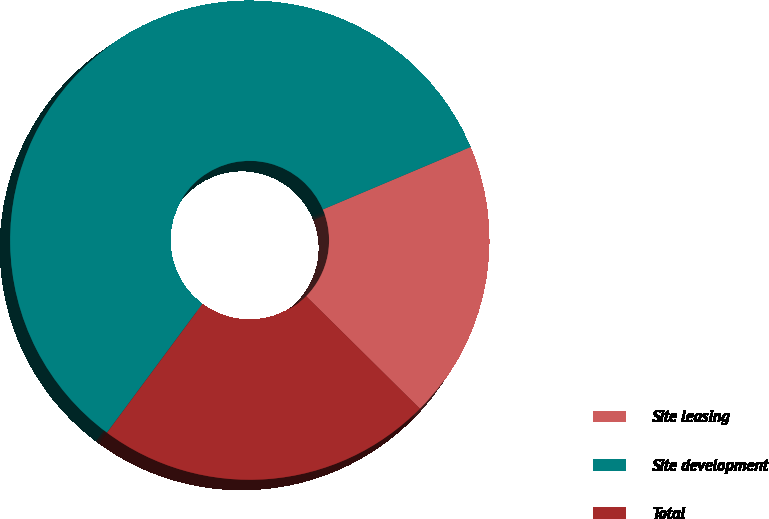Convert chart. <chart><loc_0><loc_0><loc_500><loc_500><pie_chart><fcel>Site leasing<fcel>Site development<fcel>Total<nl><fcel>18.77%<fcel>58.48%<fcel>22.74%<nl></chart> 